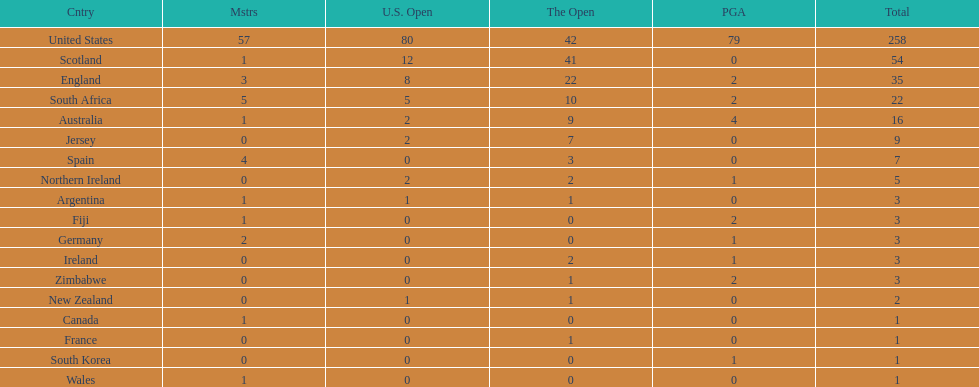Which country has the most pga championships. United States. 